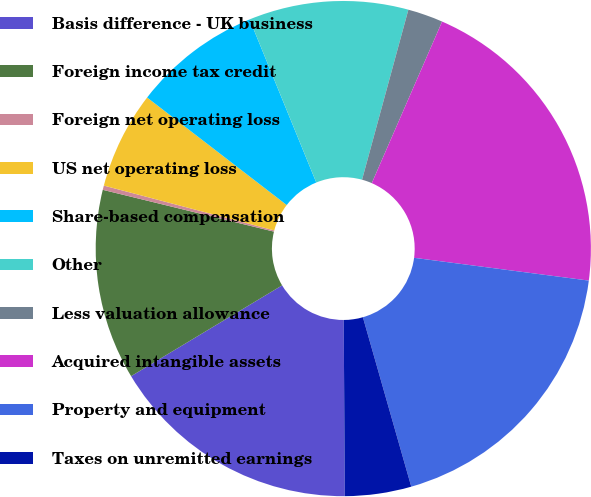Convert chart to OTSL. <chart><loc_0><loc_0><loc_500><loc_500><pie_chart><fcel>Basis difference - UK business<fcel>Foreign income tax credit<fcel>Foreign net operating loss<fcel>US net operating loss<fcel>Share-based compensation<fcel>Other<fcel>Less valuation allowance<fcel>Acquired intangible assets<fcel>Property and equipment<fcel>Taxes on unremitted earnings<nl><fcel>16.48%<fcel>12.43%<fcel>0.28%<fcel>6.35%<fcel>8.38%<fcel>10.41%<fcel>2.3%<fcel>20.53%<fcel>18.51%<fcel>4.33%<nl></chart> 